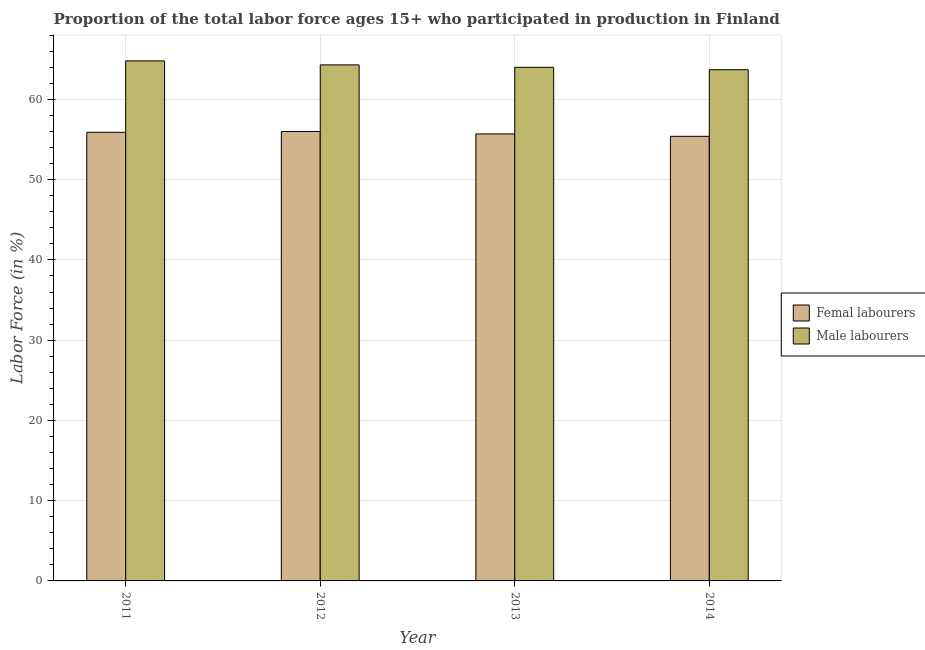How many groups of bars are there?
Give a very brief answer. 4. Are the number of bars on each tick of the X-axis equal?
Your answer should be compact. Yes. How many bars are there on the 1st tick from the left?
Make the answer very short. 2. How many bars are there on the 1st tick from the right?
Your answer should be compact. 2. What is the label of the 3rd group of bars from the left?
Keep it short and to the point. 2013. What is the percentage of female labor force in 2011?
Ensure brevity in your answer.  55.9. Across all years, what is the minimum percentage of male labour force?
Your answer should be very brief. 63.7. In which year was the percentage of male labour force maximum?
Offer a terse response. 2011. In which year was the percentage of female labor force minimum?
Make the answer very short. 2014. What is the total percentage of female labor force in the graph?
Provide a short and direct response. 223. What is the difference between the percentage of male labour force in 2013 and that in 2014?
Offer a terse response. 0.3. What is the difference between the percentage of male labour force in 2013 and the percentage of female labor force in 2014?
Your answer should be compact. 0.3. What is the average percentage of male labour force per year?
Keep it short and to the point. 64.2. In how many years, is the percentage of female labor force greater than 34 %?
Offer a very short reply. 4. What is the ratio of the percentage of male labour force in 2011 to that in 2014?
Offer a very short reply. 1.02. Is the percentage of female labor force in 2011 less than that in 2014?
Your answer should be very brief. No. Is the difference between the percentage of female labor force in 2011 and 2014 greater than the difference between the percentage of male labour force in 2011 and 2014?
Offer a terse response. No. What is the difference between the highest and the second highest percentage of female labor force?
Give a very brief answer. 0.1. What is the difference between the highest and the lowest percentage of female labor force?
Your response must be concise. 0.6. In how many years, is the percentage of female labor force greater than the average percentage of female labor force taken over all years?
Give a very brief answer. 2. Is the sum of the percentage of male labour force in 2011 and 2012 greater than the maximum percentage of female labor force across all years?
Provide a short and direct response. Yes. What does the 2nd bar from the left in 2013 represents?
Your answer should be compact. Male labourers. What does the 2nd bar from the right in 2013 represents?
Give a very brief answer. Femal labourers. How many bars are there?
Keep it short and to the point. 8. Are all the bars in the graph horizontal?
Your response must be concise. No. What is the difference between two consecutive major ticks on the Y-axis?
Make the answer very short. 10. Does the graph contain grids?
Give a very brief answer. Yes. Where does the legend appear in the graph?
Make the answer very short. Center right. What is the title of the graph?
Your answer should be compact. Proportion of the total labor force ages 15+ who participated in production in Finland. What is the Labor Force (in %) in Femal labourers in 2011?
Provide a succinct answer. 55.9. What is the Labor Force (in %) of Male labourers in 2011?
Offer a very short reply. 64.8. What is the Labor Force (in %) in Femal labourers in 2012?
Make the answer very short. 56. What is the Labor Force (in %) of Male labourers in 2012?
Your response must be concise. 64.3. What is the Labor Force (in %) of Femal labourers in 2013?
Your answer should be very brief. 55.7. What is the Labor Force (in %) in Male labourers in 2013?
Provide a short and direct response. 64. What is the Labor Force (in %) of Femal labourers in 2014?
Give a very brief answer. 55.4. What is the Labor Force (in %) in Male labourers in 2014?
Your response must be concise. 63.7. Across all years, what is the maximum Labor Force (in %) of Femal labourers?
Offer a terse response. 56. Across all years, what is the maximum Labor Force (in %) of Male labourers?
Keep it short and to the point. 64.8. Across all years, what is the minimum Labor Force (in %) of Femal labourers?
Give a very brief answer. 55.4. Across all years, what is the minimum Labor Force (in %) in Male labourers?
Provide a succinct answer. 63.7. What is the total Labor Force (in %) of Femal labourers in the graph?
Make the answer very short. 223. What is the total Labor Force (in %) in Male labourers in the graph?
Keep it short and to the point. 256.8. What is the difference between the Labor Force (in %) in Femal labourers in 2011 and that in 2012?
Give a very brief answer. -0.1. What is the difference between the Labor Force (in %) of Male labourers in 2011 and that in 2012?
Ensure brevity in your answer.  0.5. What is the difference between the Labor Force (in %) of Femal labourers in 2011 and that in 2013?
Give a very brief answer. 0.2. What is the difference between the Labor Force (in %) of Femal labourers in 2011 and that in 2014?
Make the answer very short. 0.5. What is the difference between the Labor Force (in %) of Male labourers in 2011 and that in 2014?
Your response must be concise. 1.1. What is the difference between the Labor Force (in %) in Male labourers in 2012 and that in 2013?
Your response must be concise. 0.3. What is the difference between the Labor Force (in %) in Femal labourers in 2012 and that in 2014?
Give a very brief answer. 0.6. What is the difference between the Labor Force (in %) in Male labourers in 2012 and that in 2014?
Make the answer very short. 0.6. What is the difference between the Labor Force (in %) of Male labourers in 2013 and that in 2014?
Provide a short and direct response. 0.3. What is the difference between the Labor Force (in %) in Femal labourers in 2011 and the Labor Force (in %) in Male labourers in 2012?
Provide a succinct answer. -8.4. What is the difference between the Labor Force (in %) of Femal labourers in 2011 and the Labor Force (in %) of Male labourers in 2014?
Offer a terse response. -7.8. What is the difference between the Labor Force (in %) in Femal labourers in 2012 and the Labor Force (in %) in Male labourers in 2013?
Offer a very short reply. -8. What is the difference between the Labor Force (in %) in Femal labourers in 2013 and the Labor Force (in %) in Male labourers in 2014?
Keep it short and to the point. -8. What is the average Labor Force (in %) of Femal labourers per year?
Keep it short and to the point. 55.75. What is the average Labor Force (in %) in Male labourers per year?
Make the answer very short. 64.2. In the year 2012, what is the difference between the Labor Force (in %) of Femal labourers and Labor Force (in %) of Male labourers?
Your answer should be very brief. -8.3. In the year 2014, what is the difference between the Labor Force (in %) of Femal labourers and Labor Force (in %) of Male labourers?
Ensure brevity in your answer.  -8.3. What is the ratio of the Labor Force (in %) in Male labourers in 2011 to that in 2012?
Your answer should be very brief. 1.01. What is the ratio of the Labor Force (in %) of Femal labourers in 2011 to that in 2013?
Your answer should be compact. 1. What is the ratio of the Labor Force (in %) in Male labourers in 2011 to that in 2013?
Your answer should be very brief. 1.01. What is the ratio of the Labor Force (in %) in Femal labourers in 2011 to that in 2014?
Ensure brevity in your answer.  1.01. What is the ratio of the Labor Force (in %) in Male labourers in 2011 to that in 2014?
Your response must be concise. 1.02. What is the ratio of the Labor Force (in %) of Femal labourers in 2012 to that in 2013?
Offer a very short reply. 1.01. What is the ratio of the Labor Force (in %) of Male labourers in 2012 to that in 2013?
Keep it short and to the point. 1. What is the ratio of the Labor Force (in %) of Femal labourers in 2012 to that in 2014?
Your answer should be very brief. 1.01. What is the ratio of the Labor Force (in %) of Male labourers in 2012 to that in 2014?
Offer a very short reply. 1.01. What is the ratio of the Labor Force (in %) in Femal labourers in 2013 to that in 2014?
Make the answer very short. 1.01. What is the ratio of the Labor Force (in %) in Male labourers in 2013 to that in 2014?
Give a very brief answer. 1. What is the difference between the highest and the second highest Labor Force (in %) in Male labourers?
Provide a short and direct response. 0.5. What is the difference between the highest and the lowest Labor Force (in %) in Femal labourers?
Your response must be concise. 0.6. What is the difference between the highest and the lowest Labor Force (in %) of Male labourers?
Provide a succinct answer. 1.1. 